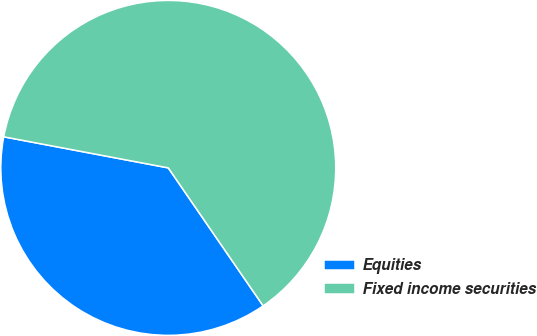<chart> <loc_0><loc_0><loc_500><loc_500><pie_chart><fcel>Equities<fcel>Fixed income securities<nl><fcel>37.56%<fcel>62.44%<nl></chart> 